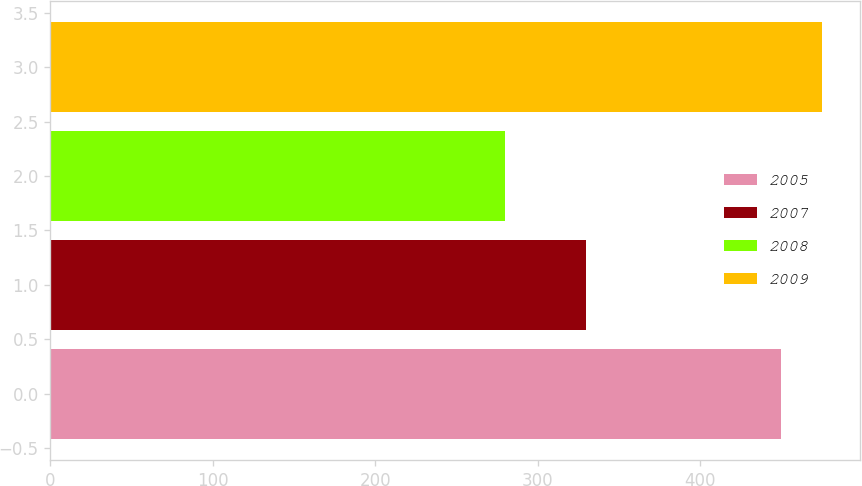Convert chart to OTSL. <chart><loc_0><loc_0><loc_500><loc_500><bar_chart><fcel>2005<fcel>2007<fcel>2008<fcel>2009<nl><fcel>450<fcel>330<fcel>280<fcel>475<nl></chart> 